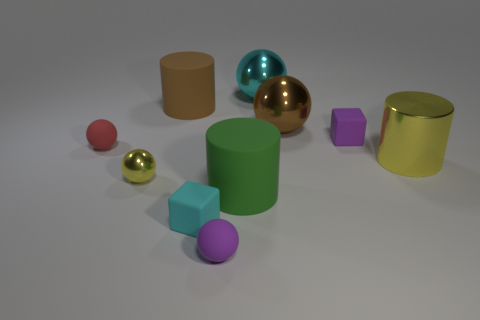How many other things are the same shape as the big green matte object?
Provide a succinct answer. 2. How many small things are cubes or yellow balls?
Keep it short and to the point. 3. There is a matte cube that is behind the red rubber ball; is it the same color as the big shiny cylinder?
Your answer should be very brief. No. Does the block that is behind the green matte cylinder have the same color as the cylinder on the right side of the large green object?
Provide a short and direct response. No. Is there a red object made of the same material as the big green thing?
Provide a succinct answer. Yes. How many green things are either shiny cylinders or big cylinders?
Your answer should be very brief. 1. Is the number of large brown things behind the large brown matte cylinder greater than the number of purple matte cylinders?
Provide a succinct answer. No. Do the brown rubber object and the brown ball have the same size?
Your response must be concise. Yes. What color is the large thing that is made of the same material as the brown cylinder?
Keep it short and to the point. Green. There is a metal object that is the same color as the large metallic cylinder; what is its shape?
Give a very brief answer. Sphere. 